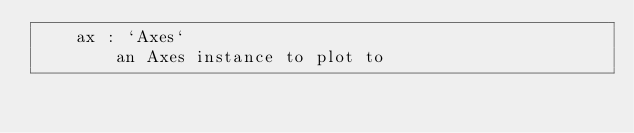Convert code to text. <code><loc_0><loc_0><loc_500><loc_500><_Python_>    ax : `Axes`
        an Axes instance to plot to</code> 